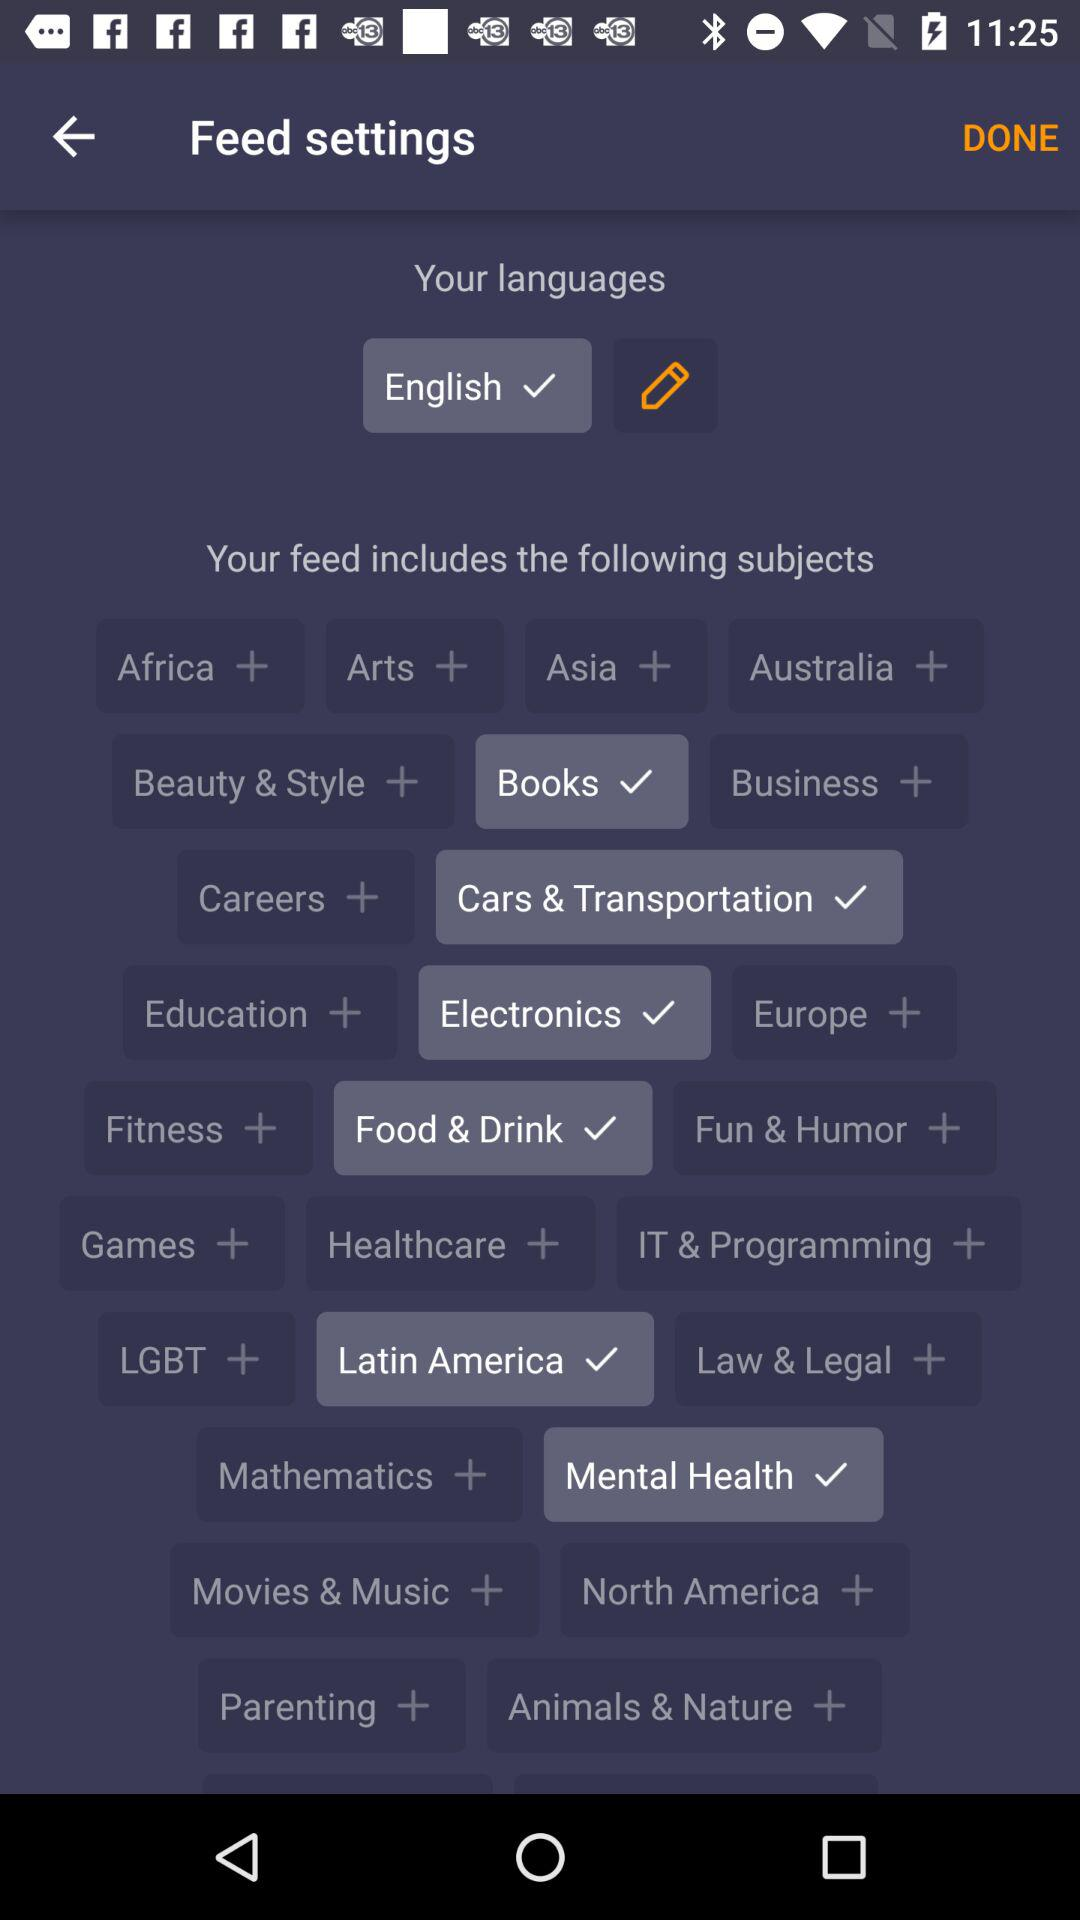Which option is selected? The selected options are "English", "Books", "Cars & Transportation", "Electronics", "Food & Drink", "Latin America" and "Mental Health". 